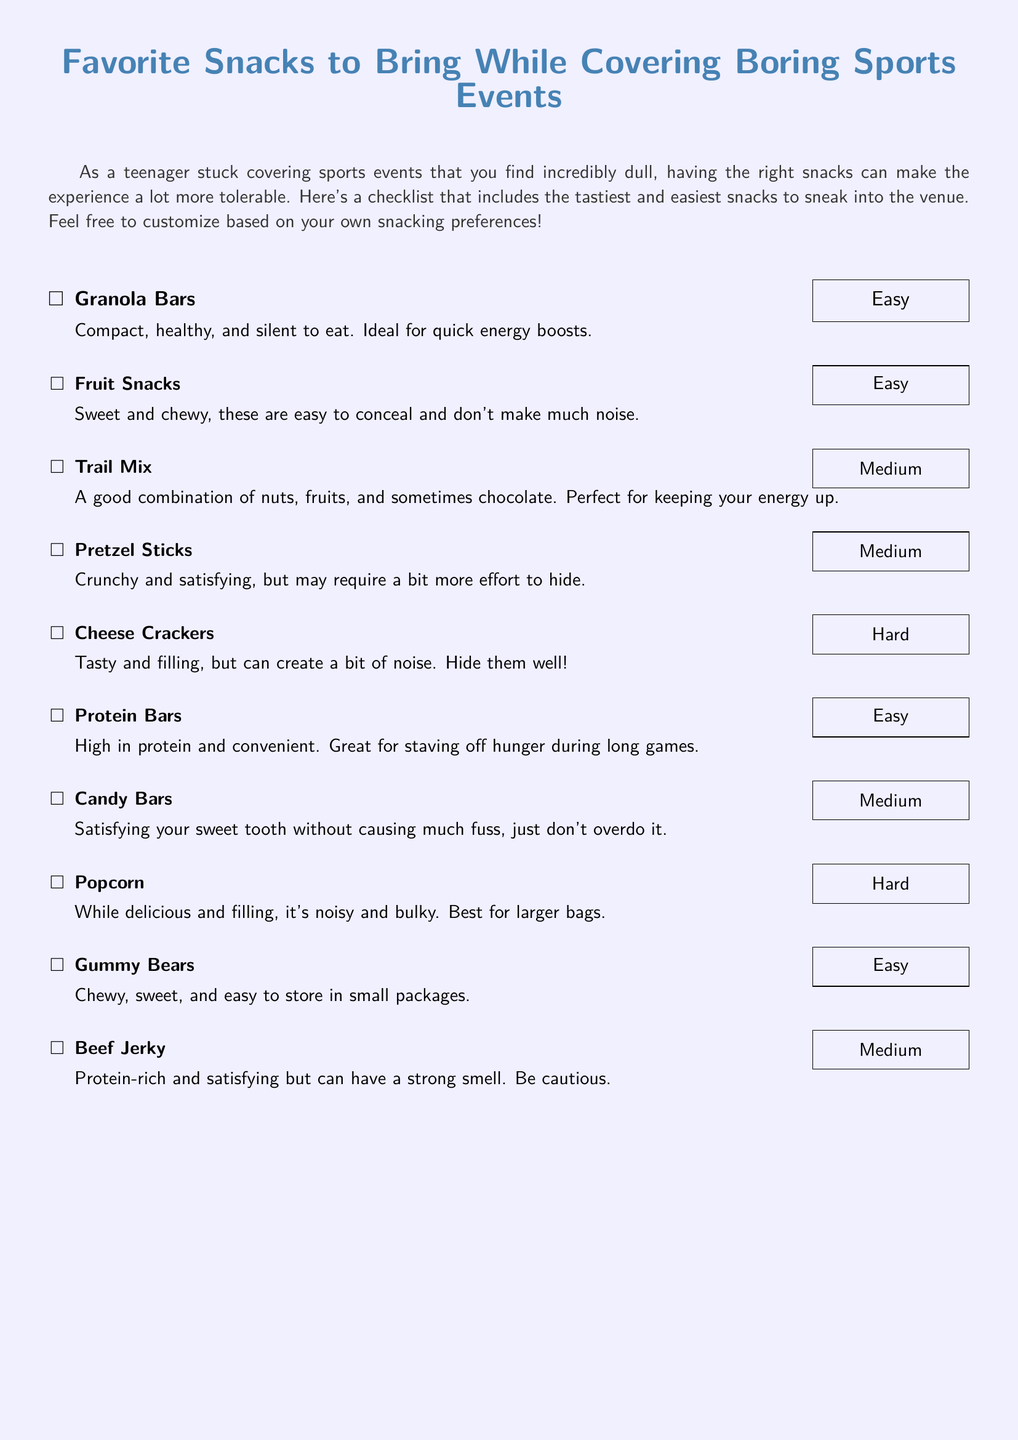What is the title of the document? The title is presented prominently at the top of the document in a larger font size.
Answer: Favorite Snacks to Bring While Covering Boring Sports Events How many snacks are listed in the document? The total number of snacks can be counted from the list provided in the document.
Answer: 10 Which snack is described as "noisy and bulky"? The snack is mentioned in the description section, indicating its characteristic noise level and size.
Answer: Popcorn What is the difficulty of sneaking in Cheese Crackers? The difficulty level is indicated next to the snack in the format of a labeled box.
Answer: Hard Which snack is high in protein and convenient? This is directly stated in the description provided for that particular snack.
Answer: Protein Bars How would you describe the sneak-in difficulty for Granola Bars? The difficulty level is explicitly indicated along with the description of the snack.
Answer: Easy What type of snack is mentioned as "sweet and chewy"? The description of this snack indicates its taste and texture type.
Answer: Fruit Snacks Which snack has a strong smell and requires caution? The strong scent is highlighted in the description, indicating it may cause issues when sneaking in.
Answer: Beef Jerky What is the texture of Gummy Bears? The description of the snack mentions its texture directly.
Answer: Chewy What combination does Trail Mix include? The ingredients are mentioned in a way that summarizes the components of this snack.
Answer: Nuts, fruits, and sometimes chocolate 